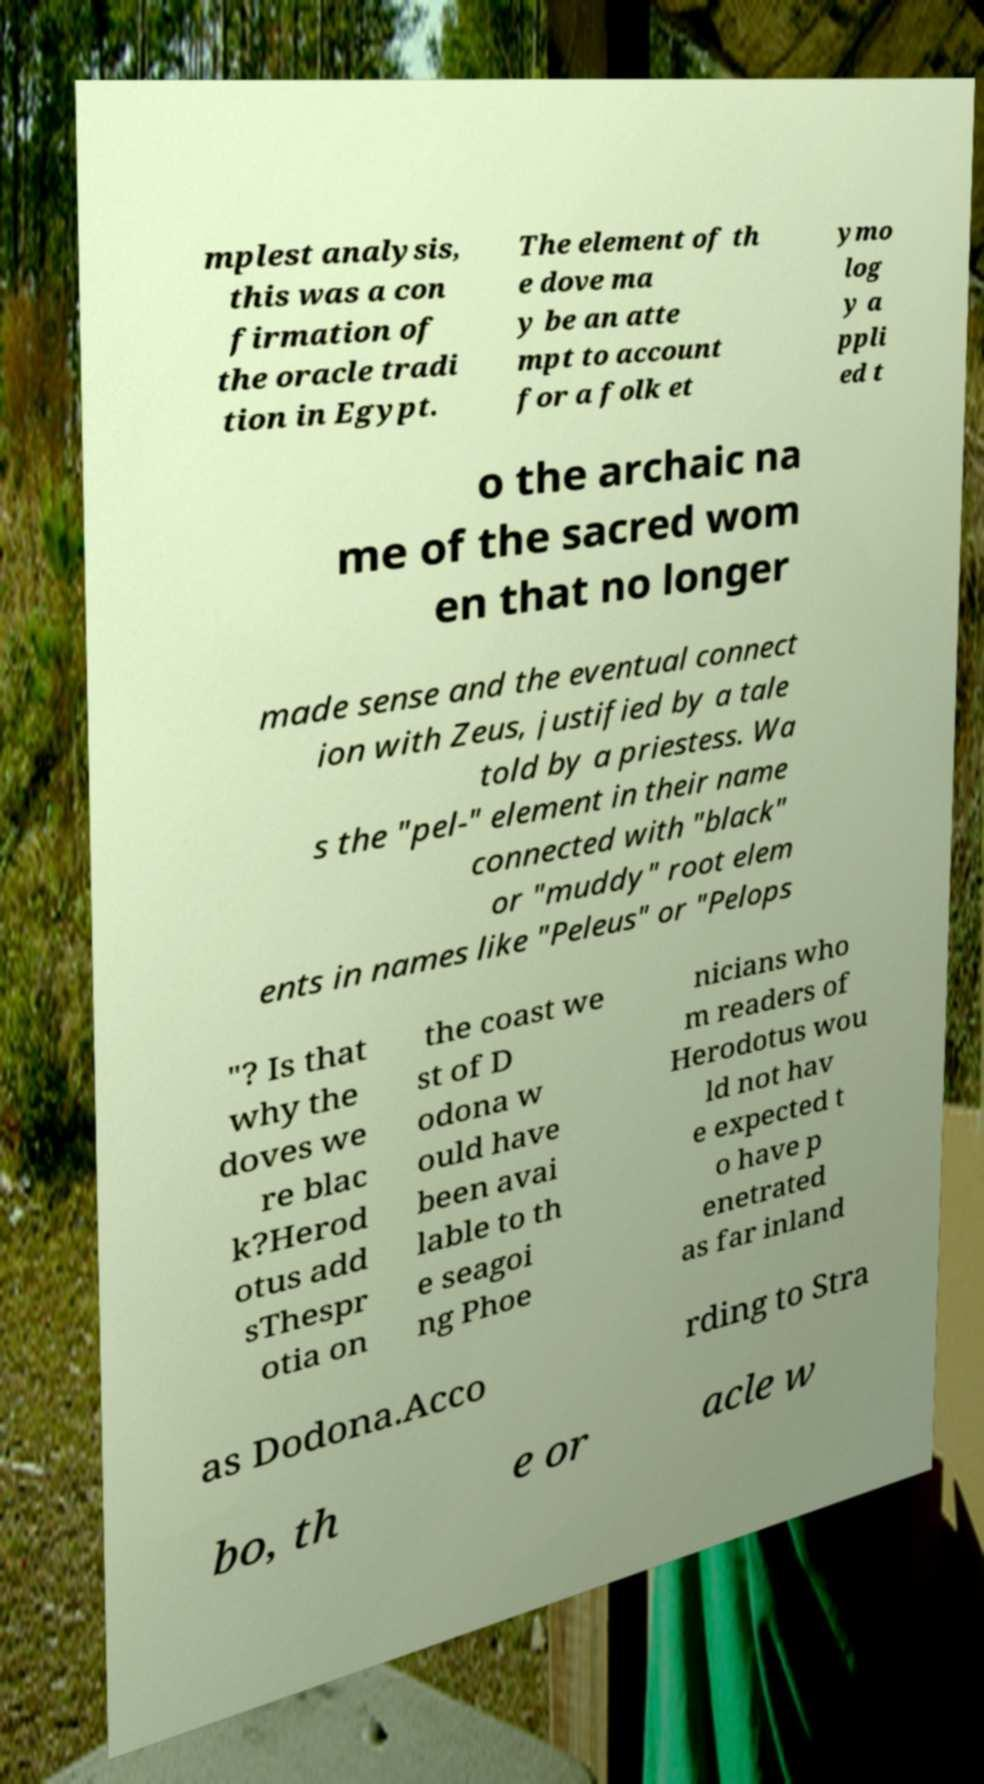For documentation purposes, I need the text within this image transcribed. Could you provide that? mplest analysis, this was a con firmation of the oracle tradi tion in Egypt. The element of th e dove ma y be an atte mpt to account for a folk et ymo log y a ppli ed t o the archaic na me of the sacred wom en that no longer made sense and the eventual connect ion with Zeus, justified by a tale told by a priestess. Wa s the "pel-" element in their name connected with "black" or "muddy" root elem ents in names like "Peleus" or "Pelops "? Is that why the doves we re blac k?Herod otus add sThespr otia on the coast we st of D odona w ould have been avai lable to th e seagoi ng Phoe nicians who m readers of Herodotus wou ld not hav e expected t o have p enetrated as far inland as Dodona.Acco rding to Stra bo, th e or acle w 